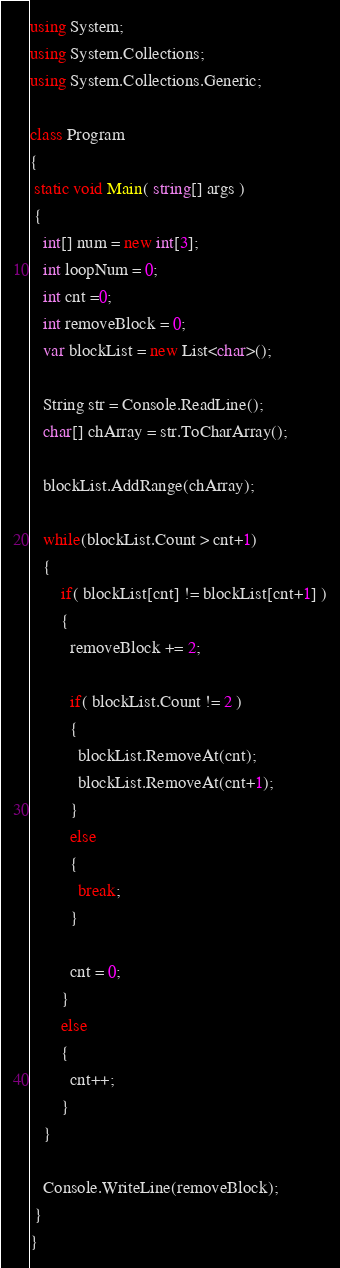Convert code to text. <code><loc_0><loc_0><loc_500><loc_500><_C#_>using System;
using System.Collections;
using System.Collections.Generic;

class Program
{
 static void Main( string[] args )
 {
   int[] num = new int[3];
   int loopNum = 0;
   int cnt =0;
   int removeBlock = 0;
   var blockList = new List<char>();
   
   String str = Console.ReadLine();
   char[] chArray = str.ToCharArray();
   
   blockList.AddRange(chArray);
   
   while(blockList.Count > cnt+1)
   {
       if( blockList[cnt] != blockList[cnt+1] )
       {
         removeBlock += 2;

         if( blockList.Count != 2 )
         {
           blockList.RemoveAt(cnt);           
           blockList.RemoveAt(cnt+1);
         }
         else
         {
           break;
         }

         cnt = 0;
       }
       else
       {
         cnt++;
       }
   }

   Console.WriteLine(removeBlock);
 }
}

</code> 